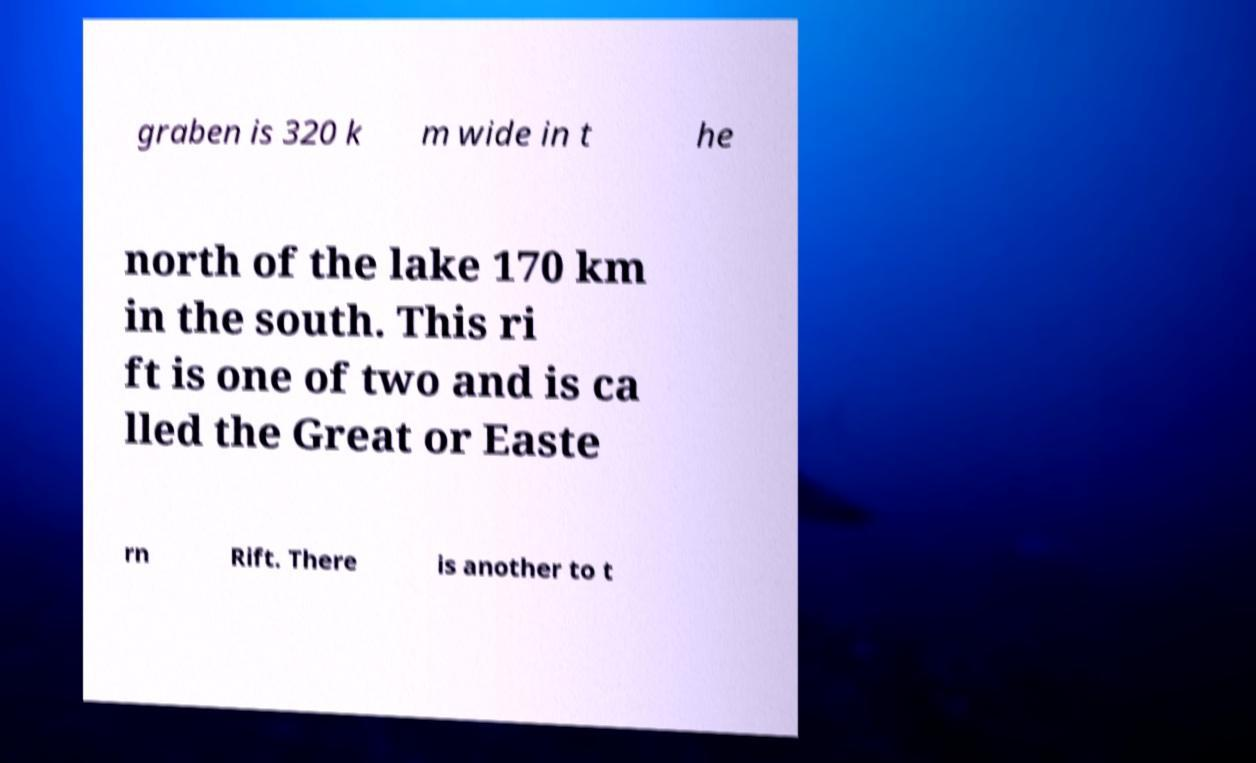For documentation purposes, I need the text within this image transcribed. Could you provide that? graben is 320 k m wide in t he north of the lake 170 km in the south. This ri ft is one of two and is ca lled the Great or Easte rn Rift. There is another to t 